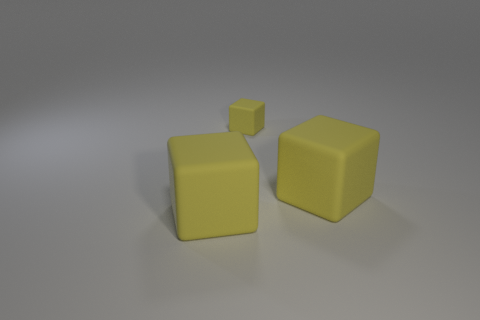Subtract all big matte cubes. How many cubes are left? 1 Subtract 0 brown balls. How many objects are left? 3 Subtract 1 blocks. How many blocks are left? 2 Subtract all cyan cubes. Subtract all gray balls. How many cubes are left? 3 Subtract all cyan cylinders. How many green blocks are left? 0 Subtract all tiny yellow things. Subtract all tiny gray matte objects. How many objects are left? 2 Add 1 matte objects. How many matte objects are left? 4 Add 3 yellow blocks. How many yellow blocks exist? 6 Add 3 yellow cubes. How many objects exist? 6 